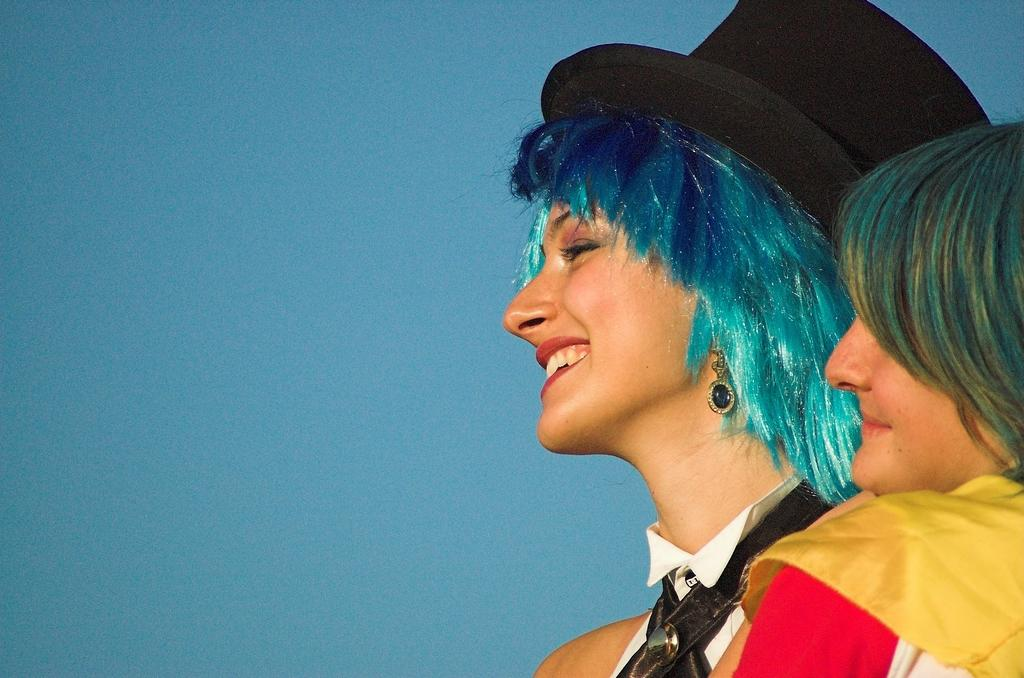Who is present in the image? There are persons in the image. What are the persons doing in the image? The persons are smiling. Can you describe the woman in the image? The woman is wearing a hat. What color is the woman's hat? The hat is black in color. What type of baseball equipment can be seen in the image? There is no baseball equipment present in the image. The focus is on the persons, their expressions, and the woman's hat. 